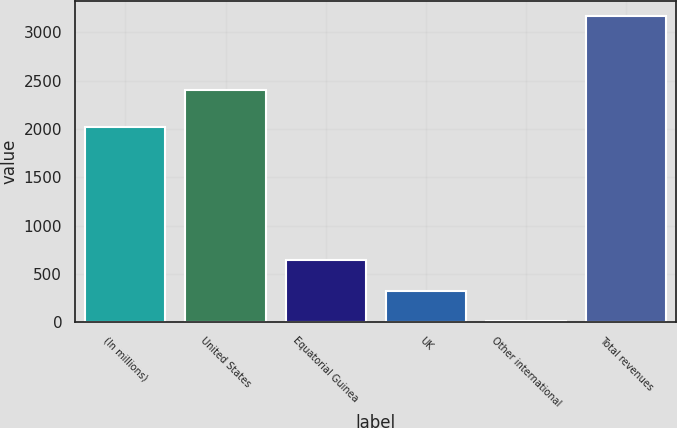<chart> <loc_0><loc_0><loc_500><loc_500><bar_chart><fcel>(In millions)<fcel>United States<fcel>Equatorial Guinea<fcel>UK<fcel>Other international<fcel>Total revenues<nl><fcel>2016<fcel>2400<fcel>641.2<fcel>325.1<fcel>9<fcel>3170<nl></chart> 